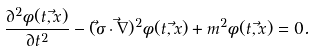<formula> <loc_0><loc_0><loc_500><loc_500>\frac { \partial ^ { 2 } \phi ( t , \vec { x } ) } { \partial t ^ { 2 } } - ( \vec { \sigma } \cdot \vec { \nabla } ) ^ { 2 } \phi ( t , \vec { x } ) + m ^ { 2 } \phi ( t , \vec { x } ) = 0 .</formula> 